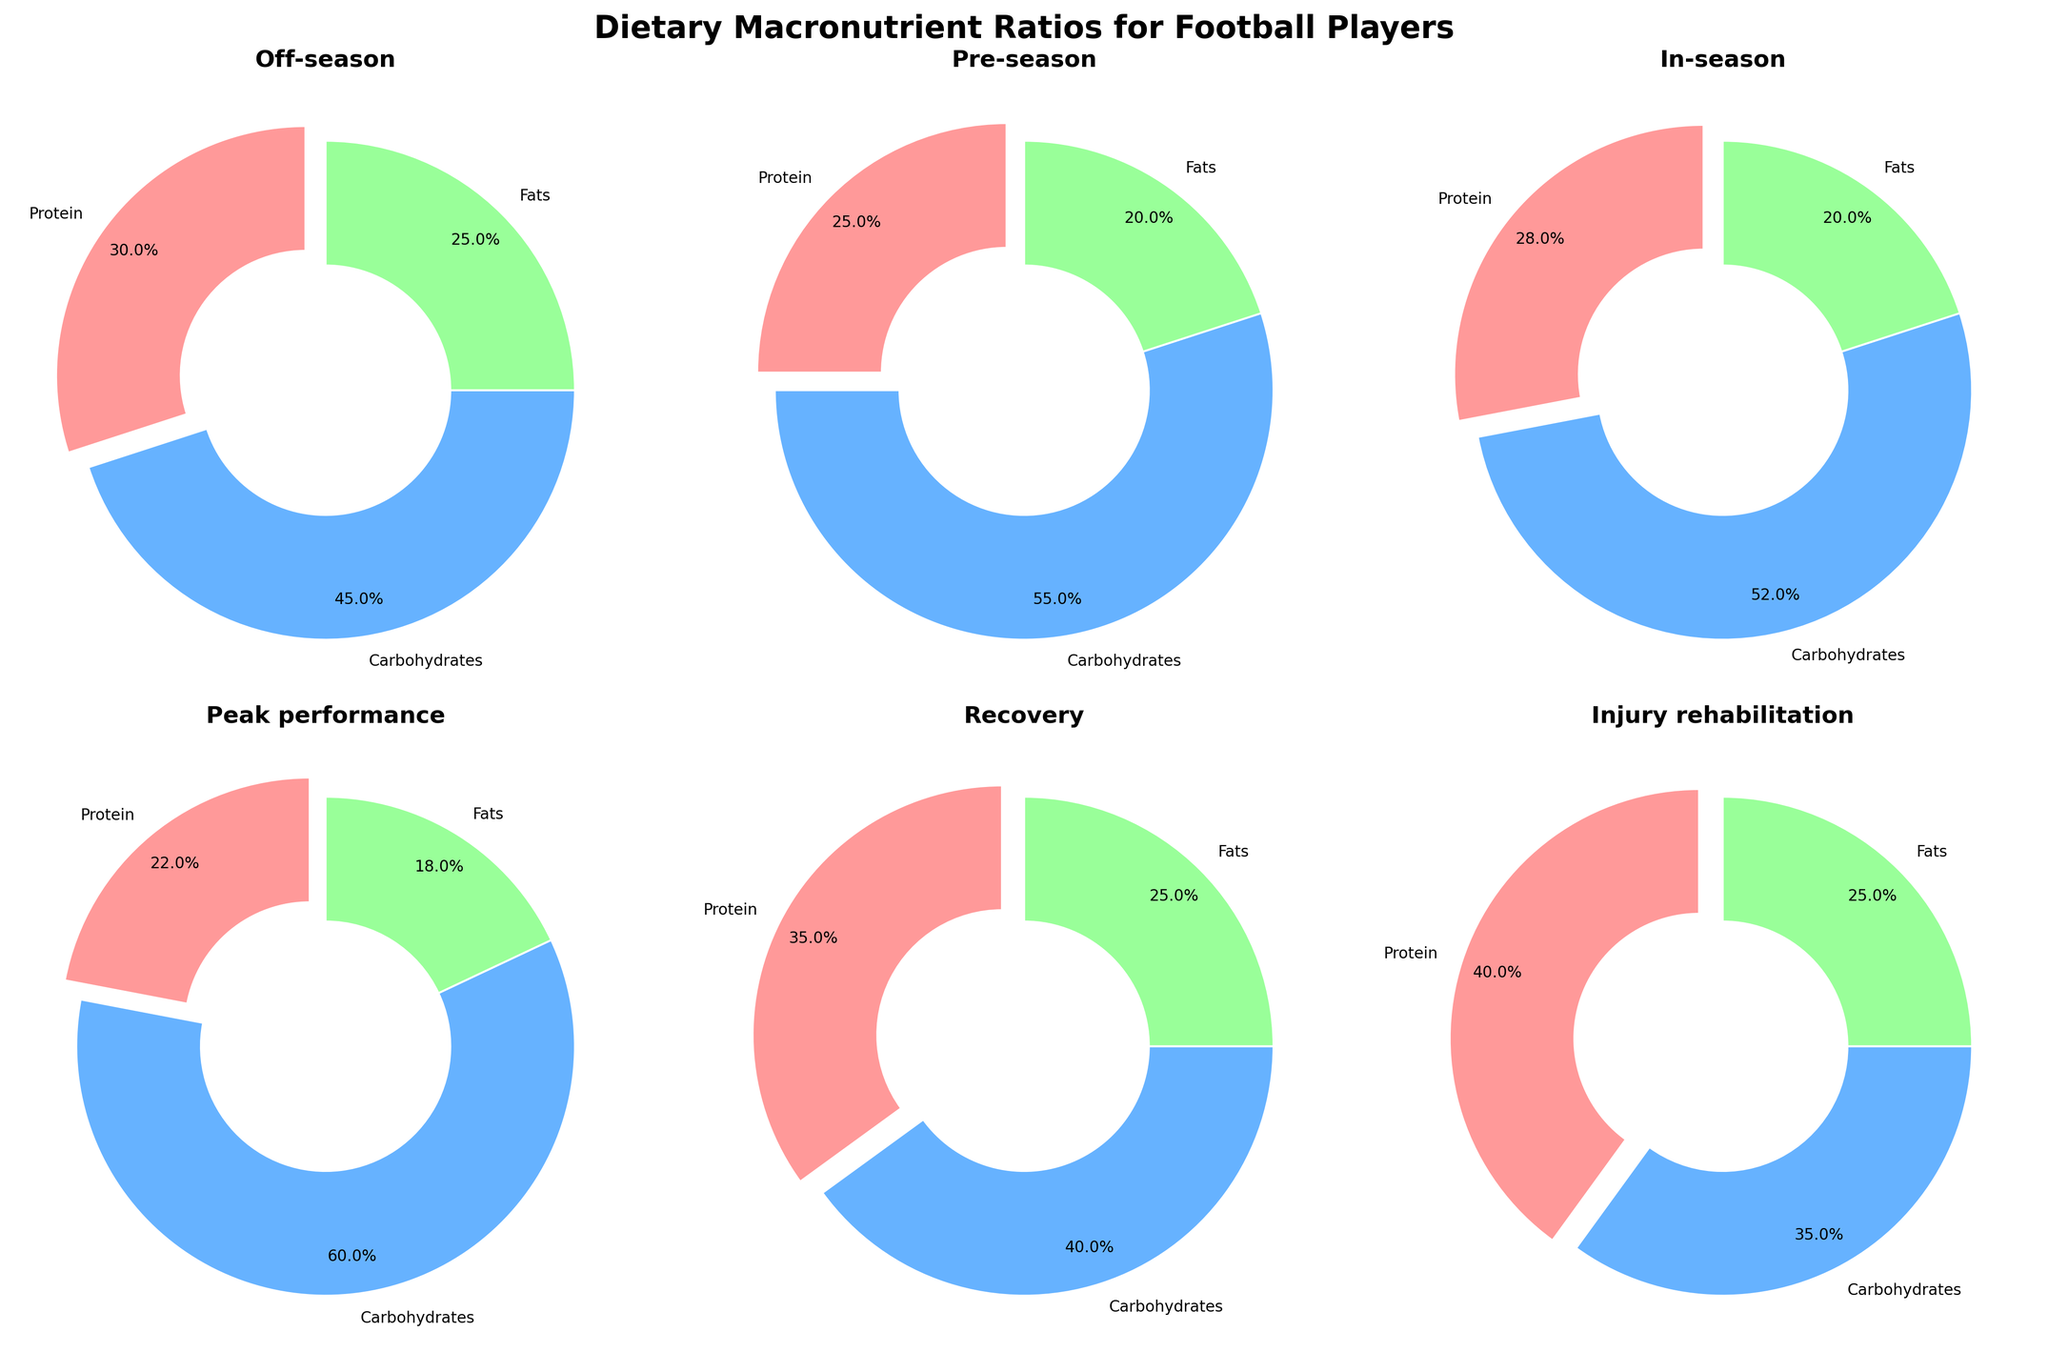Which phase has the highest percentage of carbohydrates? By looking at the charts, assess which phase chart has the largest section representing carbohydrates. Pre-season has the highest carbohydrates at 55%.
Answer: Pre-season What is the combined percentage of protein and fats in the off-season phase? In the off-season phase, protein is 30% and fats are 25%. Summing 30% and 25% gives 55%.
Answer: 55% How does the protein percentage in the injury rehabilitation phase compare to the protein percentage in the recovery phase? The injury rehabilitation phase has 40% protein, which is higher compared to the recovery phase with 35% protein.
Answer: Higher What is the difference in carbohydrate percentage between the in-season and peak performance phases? The in-season phase has 52% carbohydrates, and the peak performance phase has 60%. Subtract 52% from 60% to find the difference, which is 8%.
Answer: 8% Which phase has an equal percentage of fats and what is the percentage? By examining the charts, note that both the pre-season and in-season phases have 20% fats.
Answer: Pre-season and In-season, 20% In which phase is the percentage of protein the lowest, and what is that percentage? By reviewing the charts, the peak performance phase has the lowest protein percentage at 22%.
Answer: Peak performance, 22% What is the combined percentage of carbohydrates and fats in the recovery phase? In the recovery phase, carbohydrates are 40% and fats are 25%. Adding these together gives 65%.
Answer: 65% Which phase has the smallest segment for fats, and what is that percentage? Looking at the charts, the peak performance phase has the smallest fats segment at 18%.
Answer: Peak performance, 18% How does the percentage of fats in the off-season phase compare to the percentage of fats in the pre-season phase? The off-season phase has 25% fats, while the pre-season phase has 20% fats. The off-season phase has a higher percentage of fats.
Answer: Higher 